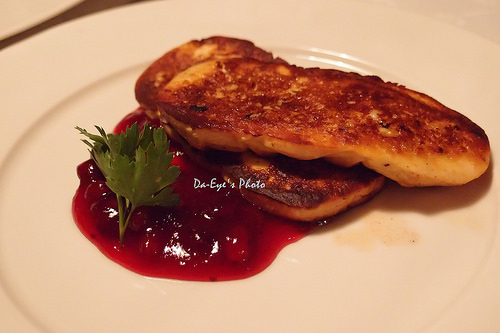<image>
Can you confirm if the meat is on the table? No. The meat is not positioned on the table. They may be near each other, but the meat is not supported by or resting on top of the table. 